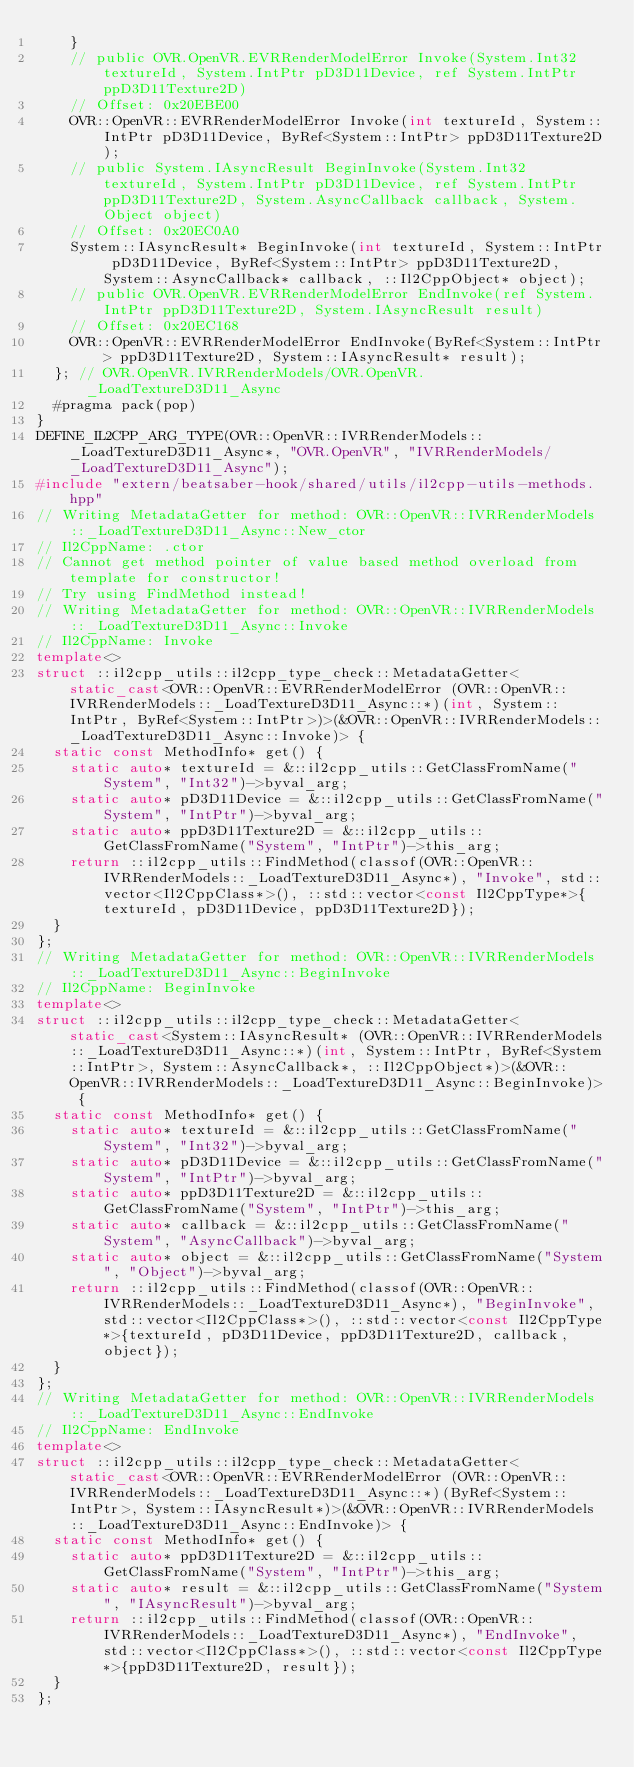<code> <loc_0><loc_0><loc_500><loc_500><_C++_>    }
    // public OVR.OpenVR.EVRRenderModelError Invoke(System.Int32 textureId, System.IntPtr pD3D11Device, ref System.IntPtr ppD3D11Texture2D)
    // Offset: 0x20EBE00
    OVR::OpenVR::EVRRenderModelError Invoke(int textureId, System::IntPtr pD3D11Device, ByRef<System::IntPtr> ppD3D11Texture2D);
    // public System.IAsyncResult BeginInvoke(System.Int32 textureId, System.IntPtr pD3D11Device, ref System.IntPtr ppD3D11Texture2D, System.AsyncCallback callback, System.Object object)
    // Offset: 0x20EC0A0
    System::IAsyncResult* BeginInvoke(int textureId, System::IntPtr pD3D11Device, ByRef<System::IntPtr> ppD3D11Texture2D, System::AsyncCallback* callback, ::Il2CppObject* object);
    // public OVR.OpenVR.EVRRenderModelError EndInvoke(ref System.IntPtr ppD3D11Texture2D, System.IAsyncResult result)
    // Offset: 0x20EC168
    OVR::OpenVR::EVRRenderModelError EndInvoke(ByRef<System::IntPtr> ppD3D11Texture2D, System::IAsyncResult* result);
  }; // OVR.OpenVR.IVRRenderModels/OVR.OpenVR._LoadTextureD3D11_Async
  #pragma pack(pop)
}
DEFINE_IL2CPP_ARG_TYPE(OVR::OpenVR::IVRRenderModels::_LoadTextureD3D11_Async*, "OVR.OpenVR", "IVRRenderModels/_LoadTextureD3D11_Async");
#include "extern/beatsaber-hook/shared/utils/il2cpp-utils-methods.hpp"
// Writing MetadataGetter for method: OVR::OpenVR::IVRRenderModels::_LoadTextureD3D11_Async::New_ctor
// Il2CppName: .ctor
// Cannot get method pointer of value based method overload from template for constructor!
// Try using FindMethod instead!
// Writing MetadataGetter for method: OVR::OpenVR::IVRRenderModels::_LoadTextureD3D11_Async::Invoke
// Il2CppName: Invoke
template<>
struct ::il2cpp_utils::il2cpp_type_check::MetadataGetter<static_cast<OVR::OpenVR::EVRRenderModelError (OVR::OpenVR::IVRRenderModels::_LoadTextureD3D11_Async::*)(int, System::IntPtr, ByRef<System::IntPtr>)>(&OVR::OpenVR::IVRRenderModels::_LoadTextureD3D11_Async::Invoke)> {
  static const MethodInfo* get() {
    static auto* textureId = &::il2cpp_utils::GetClassFromName("System", "Int32")->byval_arg;
    static auto* pD3D11Device = &::il2cpp_utils::GetClassFromName("System", "IntPtr")->byval_arg;
    static auto* ppD3D11Texture2D = &::il2cpp_utils::GetClassFromName("System", "IntPtr")->this_arg;
    return ::il2cpp_utils::FindMethod(classof(OVR::OpenVR::IVRRenderModels::_LoadTextureD3D11_Async*), "Invoke", std::vector<Il2CppClass*>(), ::std::vector<const Il2CppType*>{textureId, pD3D11Device, ppD3D11Texture2D});
  }
};
// Writing MetadataGetter for method: OVR::OpenVR::IVRRenderModels::_LoadTextureD3D11_Async::BeginInvoke
// Il2CppName: BeginInvoke
template<>
struct ::il2cpp_utils::il2cpp_type_check::MetadataGetter<static_cast<System::IAsyncResult* (OVR::OpenVR::IVRRenderModels::_LoadTextureD3D11_Async::*)(int, System::IntPtr, ByRef<System::IntPtr>, System::AsyncCallback*, ::Il2CppObject*)>(&OVR::OpenVR::IVRRenderModels::_LoadTextureD3D11_Async::BeginInvoke)> {
  static const MethodInfo* get() {
    static auto* textureId = &::il2cpp_utils::GetClassFromName("System", "Int32")->byval_arg;
    static auto* pD3D11Device = &::il2cpp_utils::GetClassFromName("System", "IntPtr")->byval_arg;
    static auto* ppD3D11Texture2D = &::il2cpp_utils::GetClassFromName("System", "IntPtr")->this_arg;
    static auto* callback = &::il2cpp_utils::GetClassFromName("System", "AsyncCallback")->byval_arg;
    static auto* object = &::il2cpp_utils::GetClassFromName("System", "Object")->byval_arg;
    return ::il2cpp_utils::FindMethod(classof(OVR::OpenVR::IVRRenderModels::_LoadTextureD3D11_Async*), "BeginInvoke", std::vector<Il2CppClass*>(), ::std::vector<const Il2CppType*>{textureId, pD3D11Device, ppD3D11Texture2D, callback, object});
  }
};
// Writing MetadataGetter for method: OVR::OpenVR::IVRRenderModels::_LoadTextureD3D11_Async::EndInvoke
// Il2CppName: EndInvoke
template<>
struct ::il2cpp_utils::il2cpp_type_check::MetadataGetter<static_cast<OVR::OpenVR::EVRRenderModelError (OVR::OpenVR::IVRRenderModels::_LoadTextureD3D11_Async::*)(ByRef<System::IntPtr>, System::IAsyncResult*)>(&OVR::OpenVR::IVRRenderModels::_LoadTextureD3D11_Async::EndInvoke)> {
  static const MethodInfo* get() {
    static auto* ppD3D11Texture2D = &::il2cpp_utils::GetClassFromName("System", "IntPtr")->this_arg;
    static auto* result = &::il2cpp_utils::GetClassFromName("System", "IAsyncResult")->byval_arg;
    return ::il2cpp_utils::FindMethod(classof(OVR::OpenVR::IVRRenderModels::_LoadTextureD3D11_Async*), "EndInvoke", std::vector<Il2CppClass*>(), ::std::vector<const Il2CppType*>{ppD3D11Texture2D, result});
  }
};
</code> 